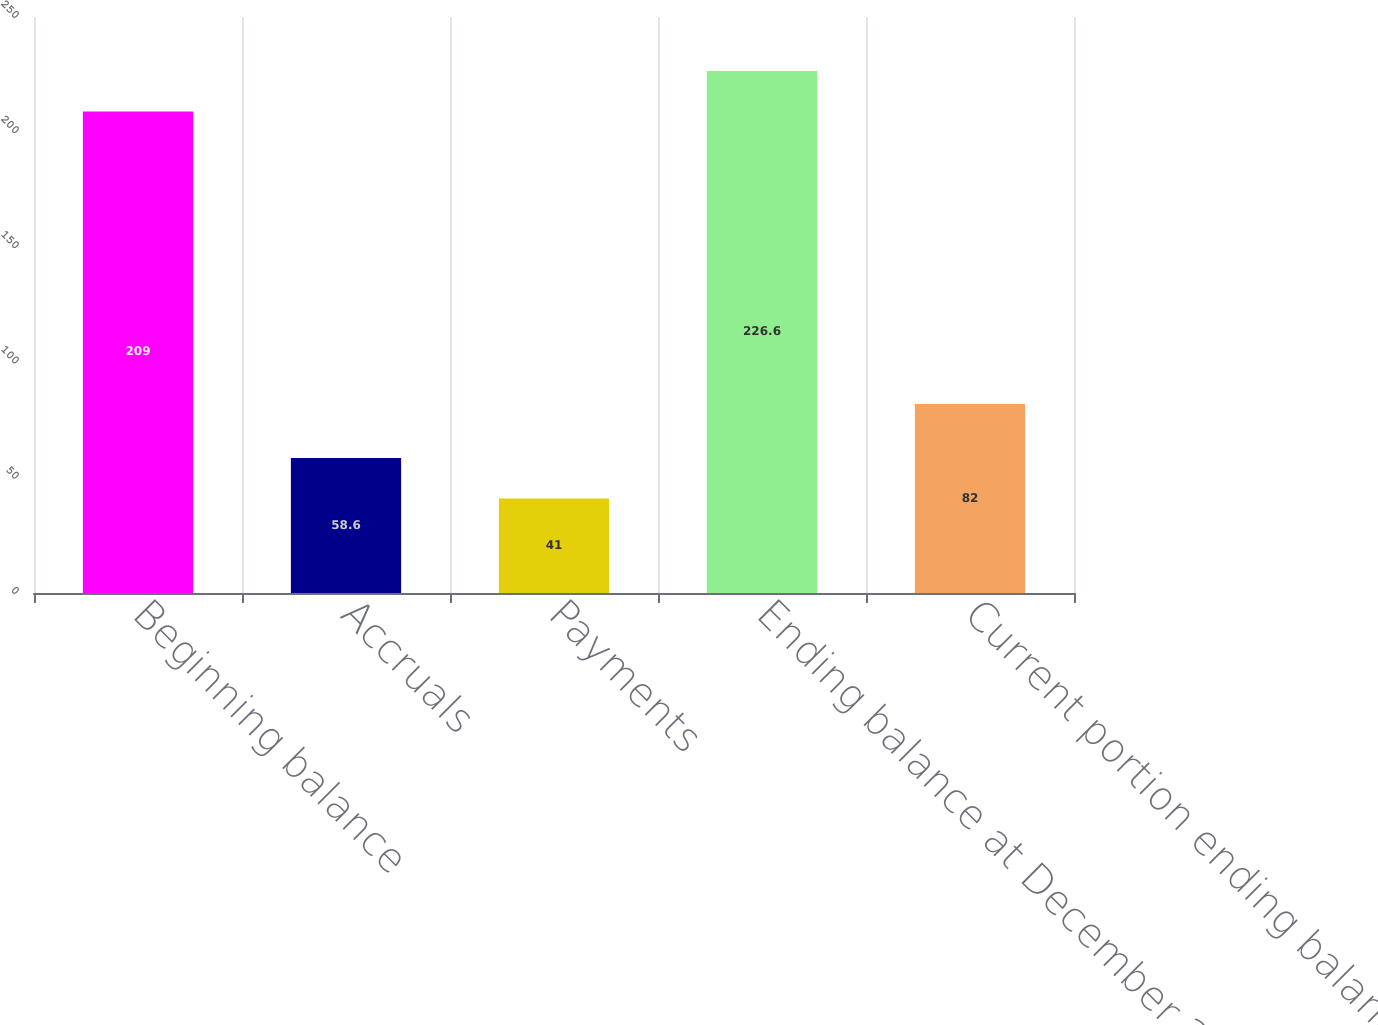<chart> <loc_0><loc_0><loc_500><loc_500><bar_chart><fcel>Beginning balance<fcel>Accruals<fcel>Payments<fcel>Ending balance at December 31<fcel>Current portion ending balance<nl><fcel>209<fcel>58.6<fcel>41<fcel>226.6<fcel>82<nl></chart> 